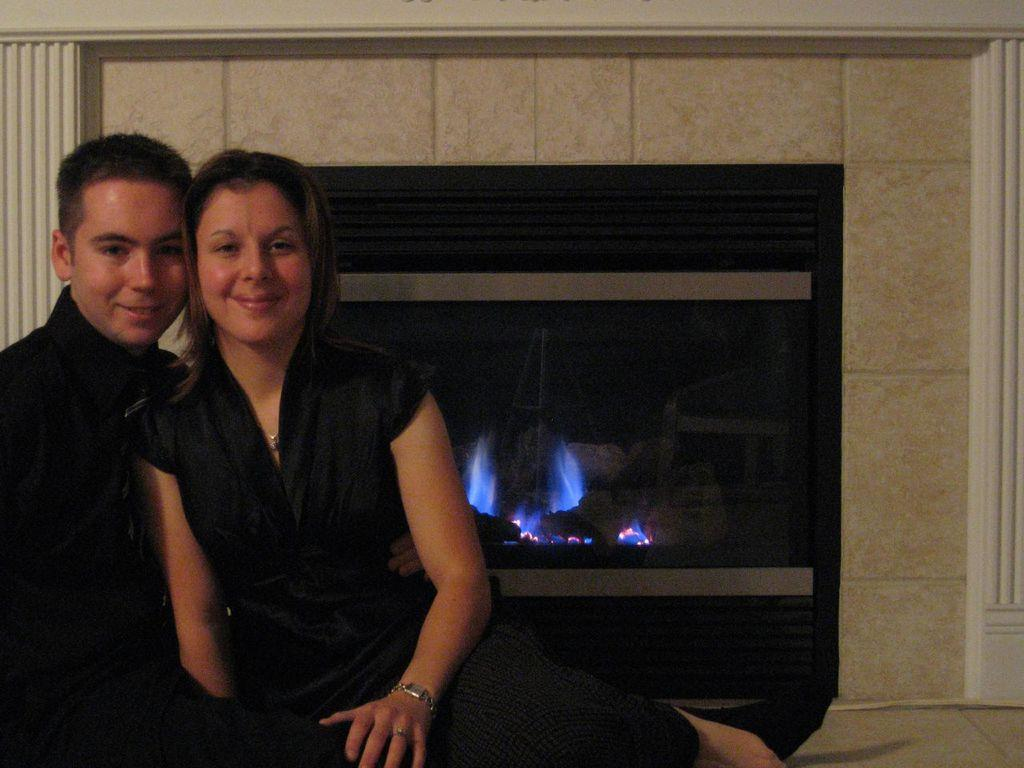How many people are in the image? There are two persons in the image. What expressions do the people have in the image? The two persons are smiling. What can be seen in the background of the image? There is a fireplace in the background of the image. What type of corn is being cooked in the fireplace in the image? There is no corn present in the image, and the fireplace is not being used for cooking. Can you see any goldfish swimming in the fireplace in the image? There are no goldfish present in the image, and the fireplace is not a suitable environment for goldfish. 